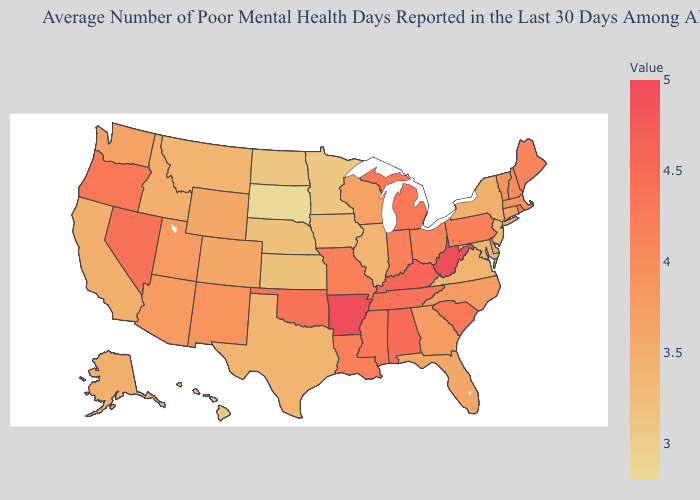Among the states that border Mississippi , which have the highest value?
Quick response, please. Arkansas. Does South Dakota have the lowest value in the USA?
Short answer required. Yes. Among the states that border Kansas , does Oklahoma have the lowest value?
Be succinct. No. Does Indiana have the highest value in the USA?
Keep it brief. No. Among the states that border Maryland , which have the highest value?
Be succinct. West Virginia. 